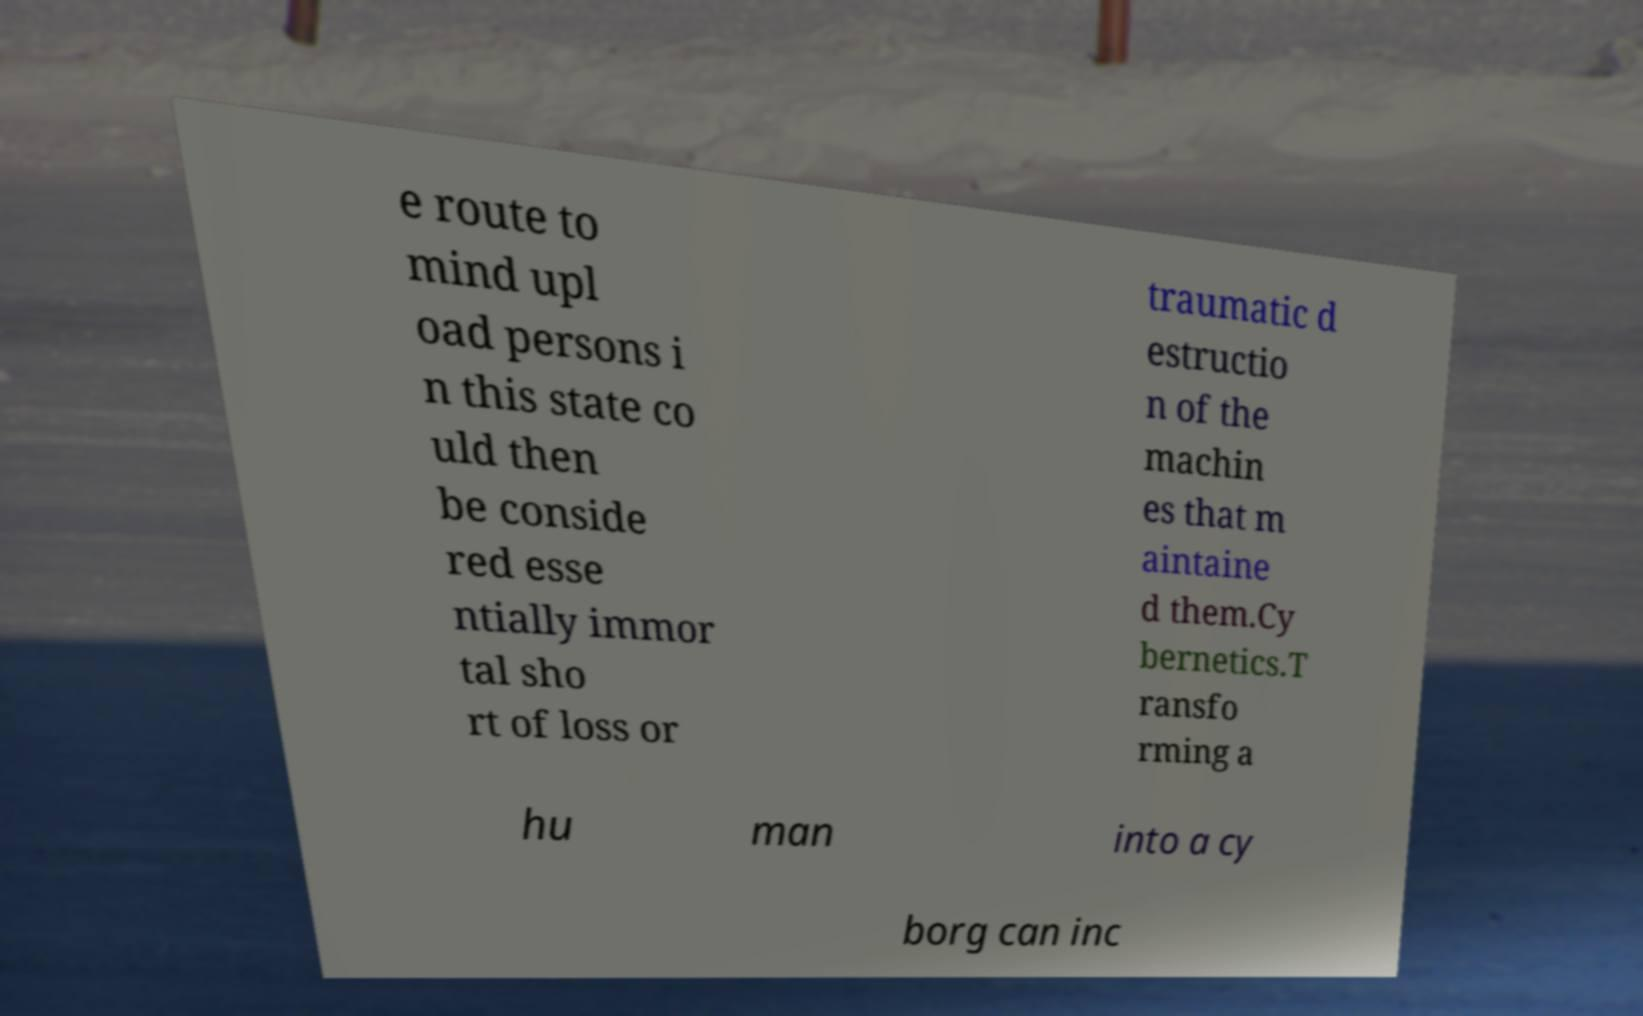Please identify and transcribe the text found in this image. e route to mind upl oad persons i n this state co uld then be conside red esse ntially immor tal sho rt of loss or traumatic d estructio n of the machin es that m aintaine d them.Cy bernetics.T ransfo rming a hu man into a cy borg can inc 